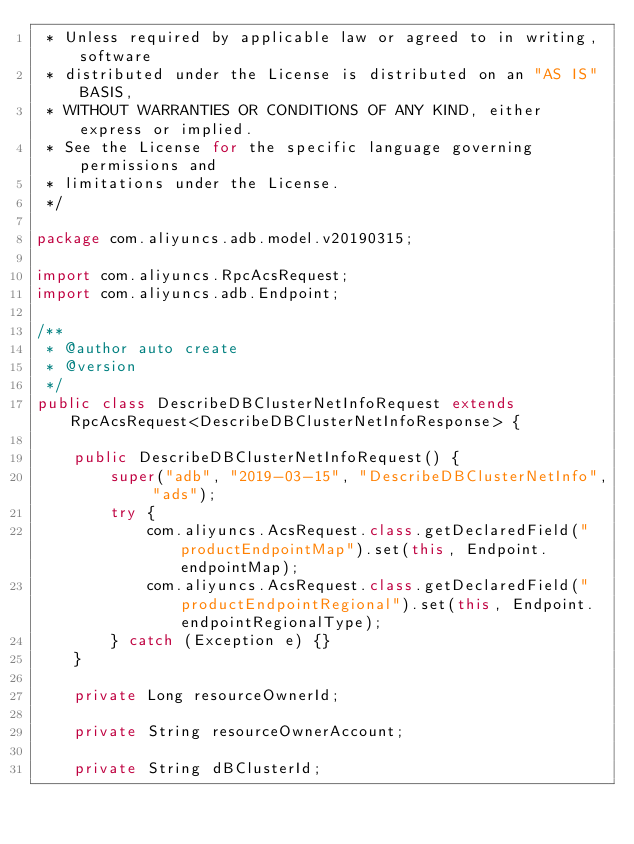<code> <loc_0><loc_0><loc_500><loc_500><_Java_> * Unless required by applicable law or agreed to in writing, software
 * distributed under the License is distributed on an "AS IS" BASIS,
 * WITHOUT WARRANTIES OR CONDITIONS OF ANY KIND, either express or implied.
 * See the License for the specific language governing permissions and
 * limitations under the License.
 */

package com.aliyuncs.adb.model.v20190315;

import com.aliyuncs.RpcAcsRequest;
import com.aliyuncs.adb.Endpoint;

/**
 * @author auto create
 * @version 
 */
public class DescribeDBClusterNetInfoRequest extends RpcAcsRequest<DescribeDBClusterNetInfoResponse> {
	
	public DescribeDBClusterNetInfoRequest() {
		super("adb", "2019-03-15", "DescribeDBClusterNetInfo", "ads");
		try {
			com.aliyuncs.AcsRequest.class.getDeclaredField("productEndpointMap").set(this, Endpoint.endpointMap);
			com.aliyuncs.AcsRequest.class.getDeclaredField("productEndpointRegional").set(this, Endpoint.endpointRegionalType);
		} catch (Exception e) {}
	}

	private Long resourceOwnerId;

	private String resourceOwnerAccount;

	private String dBClusterId;
</code> 